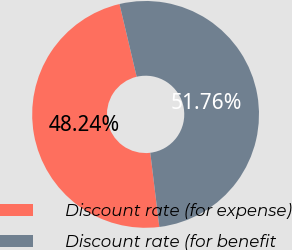<chart> <loc_0><loc_0><loc_500><loc_500><pie_chart><fcel>Discount rate (for expense)<fcel>Discount rate (for benefit<nl><fcel>48.24%<fcel>51.76%<nl></chart> 